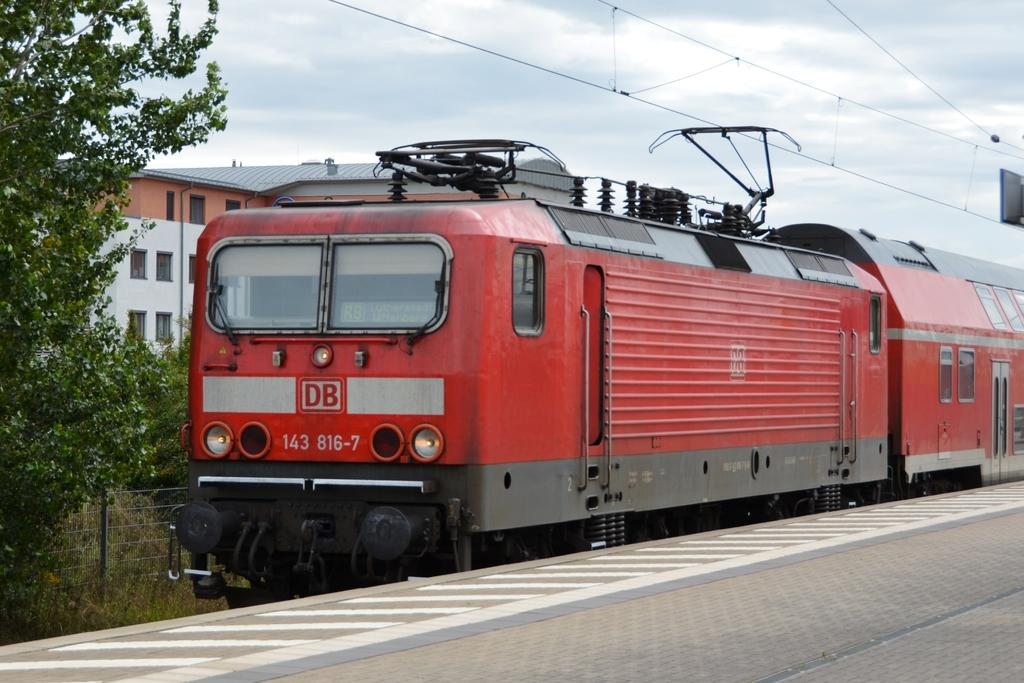<image>
Summarize the visual content of the image. A red DB 143 816-7 train is sitting on the tracks. 